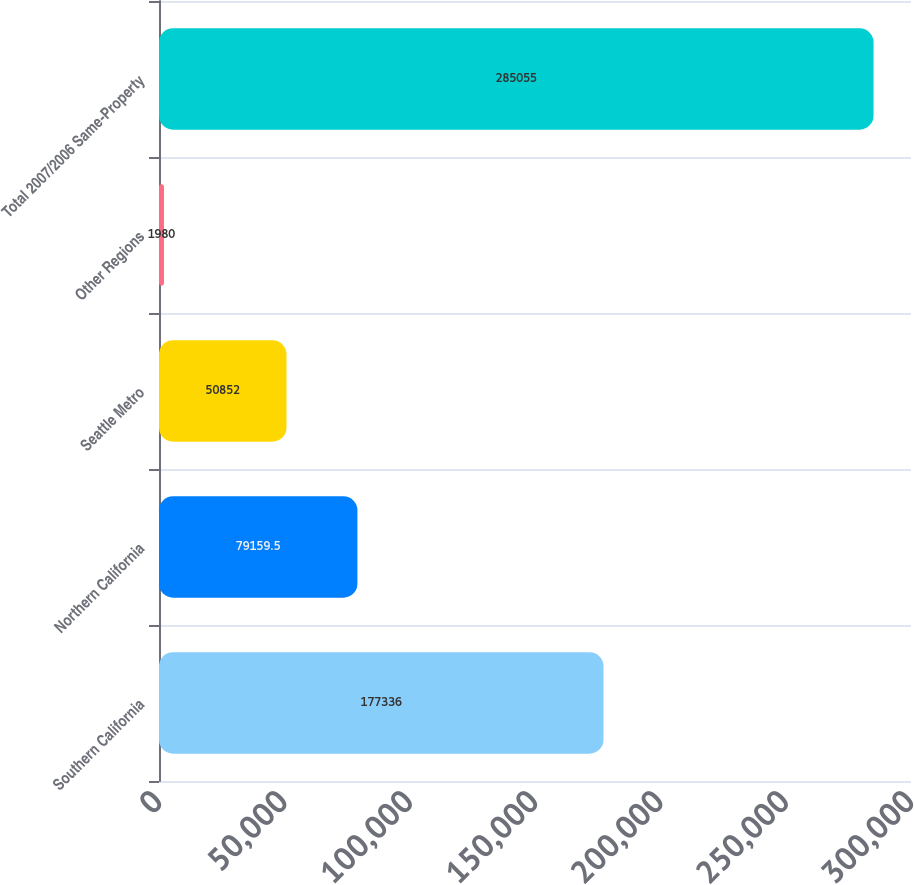Convert chart. <chart><loc_0><loc_0><loc_500><loc_500><bar_chart><fcel>Southern California<fcel>Northern California<fcel>Seattle Metro<fcel>Other Regions<fcel>Total 2007/2006 Same-Property<nl><fcel>177336<fcel>79159.5<fcel>50852<fcel>1980<fcel>285055<nl></chart> 